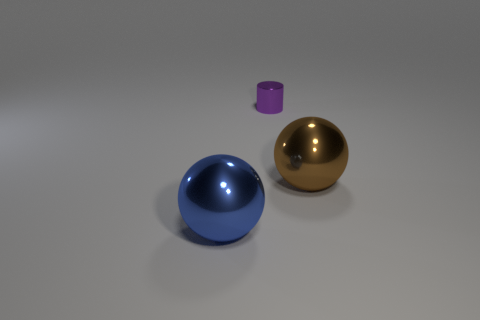Add 1 big gray matte things. How many objects exist? 4 Subtract all spheres. How many objects are left? 1 Add 1 blue shiny balls. How many blue shiny balls are left? 2 Add 1 tiny cyan spheres. How many tiny cyan spheres exist? 1 Subtract 0 gray blocks. How many objects are left? 3 Subtract all purple metal objects. Subtract all small purple metallic things. How many objects are left? 1 